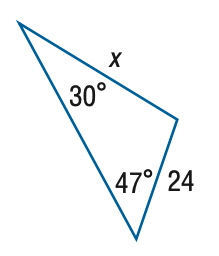Answer the mathemtical geometry problem and directly provide the correct option letter.
Question: Find x. Round side measure to the nearest tenth.
Choices: A: 16.4 B: 18.0 C: 32.0 D: 35.1 D 